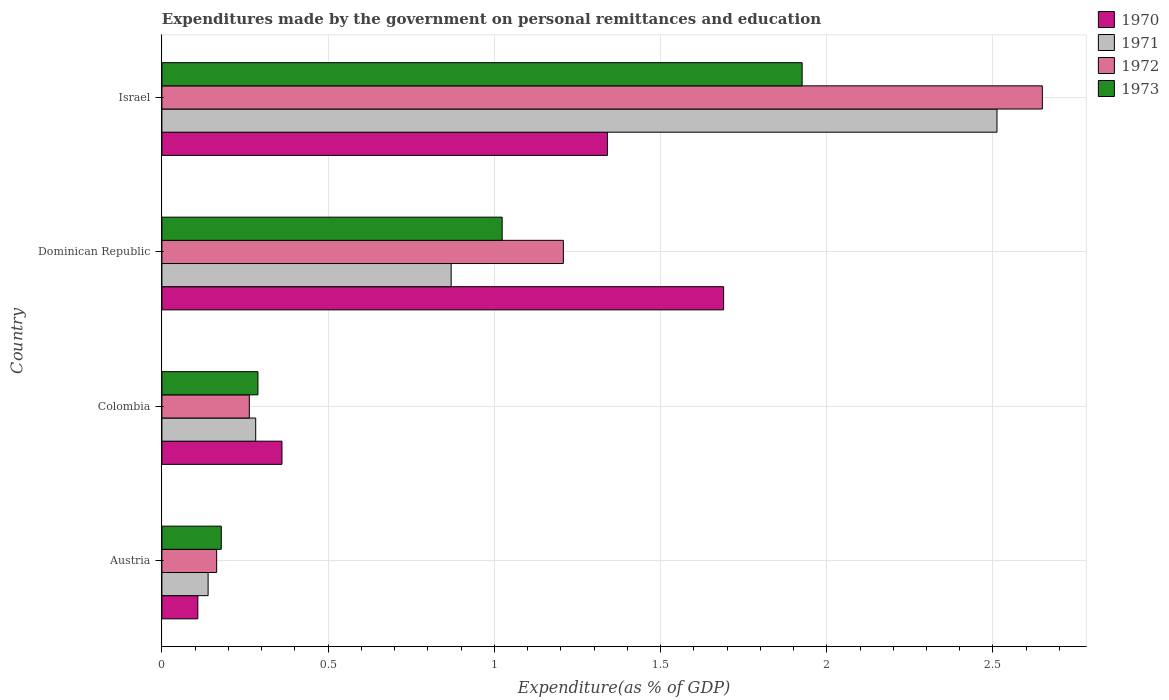How many different coloured bars are there?
Offer a very short reply. 4. How many groups of bars are there?
Your response must be concise. 4. Are the number of bars on each tick of the Y-axis equal?
Offer a very short reply. Yes. How many bars are there on the 1st tick from the top?
Ensure brevity in your answer.  4. What is the label of the 3rd group of bars from the top?
Your answer should be compact. Colombia. What is the expenditures made by the government on personal remittances and education in 1971 in Colombia?
Your response must be concise. 0.28. Across all countries, what is the maximum expenditures made by the government on personal remittances and education in 1973?
Offer a very short reply. 1.93. Across all countries, what is the minimum expenditures made by the government on personal remittances and education in 1971?
Ensure brevity in your answer.  0.14. In which country was the expenditures made by the government on personal remittances and education in 1972 maximum?
Your answer should be compact. Israel. In which country was the expenditures made by the government on personal remittances and education in 1973 minimum?
Your answer should be compact. Austria. What is the total expenditures made by the government on personal remittances and education in 1970 in the graph?
Provide a short and direct response. 3.5. What is the difference between the expenditures made by the government on personal remittances and education in 1971 in Colombia and that in Dominican Republic?
Your answer should be very brief. -0.59. What is the difference between the expenditures made by the government on personal remittances and education in 1972 in Dominican Republic and the expenditures made by the government on personal remittances and education in 1970 in Israel?
Provide a succinct answer. -0.13. What is the average expenditures made by the government on personal remittances and education in 1971 per country?
Ensure brevity in your answer.  0.95. What is the difference between the expenditures made by the government on personal remittances and education in 1973 and expenditures made by the government on personal remittances and education in 1972 in Dominican Republic?
Make the answer very short. -0.18. What is the ratio of the expenditures made by the government on personal remittances and education in 1972 in Colombia to that in Dominican Republic?
Provide a short and direct response. 0.22. Is the difference between the expenditures made by the government on personal remittances and education in 1973 in Austria and Dominican Republic greater than the difference between the expenditures made by the government on personal remittances and education in 1972 in Austria and Dominican Republic?
Give a very brief answer. Yes. What is the difference between the highest and the second highest expenditures made by the government on personal remittances and education in 1970?
Offer a terse response. 0.35. What is the difference between the highest and the lowest expenditures made by the government on personal remittances and education in 1973?
Your response must be concise. 1.75. Is it the case that in every country, the sum of the expenditures made by the government on personal remittances and education in 1971 and expenditures made by the government on personal remittances and education in 1970 is greater than the sum of expenditures made by the government on personal remittances and education in 1973 and expenditures made by the government on personal remittances and education in 1972?
Provide a succinct answer. No. What does the 4th bar from the top in Dominican Republic represents?
Your answer should be compact. 1970. What does the 4th bar from the bottom in Dominican Republic represents?
Your answer should be very brief. 1973. Are the values on the major ticks of X-axis written in scientific E-notation?
Your answer should be compact. No. Does the graph contain any zero values?
Provide a short and direct response. No. Where does the legend appear in the graph?
Provide a succinct answer. Top right. How many legend labels are there?
Offer a terse response. 4. How are the legend labels stacked?
Provide a short and direct response. Vertical. What is the title of the graph?
Ensure brevity in your answer.  Expenditures made by the government on personal remittances and education. Does "2010" appear as one of the legend labels in the graph?
Offer a very short reply. No. What is the label or title of the X-axis?
Ensure brevity in your answer.  Expenditure(as % of GDP). What is the Expenditure(as % of GDP) of 1970 in Austria?
Offer a very short reply. 0.11. What is the Expenditure(as % of GDP) in 1971 in Austria?
Your response must be concise. 0.14. What is the Expenditure(as % of GDP) of 1972 in Austria?
Your answer should be very brief. 0.16. What is the Expenditure(as % of GDP) of 1973 in Austria?
Keep it short and to the point. 0.18. What is the Expenditure(as % of GDP) of 1970 in Colombia?
Make the answer very short. 0.36. What is the Expenditure(as % of GDP) of 1971 in Colombia?
Ensure brevity in your answer.  0.28. What is the Expenditure(as % of GDP) in 1972 in Colombia?
Keep it short and to the point. 0.26. What is the Expenditure(as % of GDP) of 1973 in Colombia?
Offer a very short reply. 0.29. What is the Expenditure(as % of GDP) in 1970 in Dominican Republic?
Give a very brief answer. 1.69. What is the Expenditure(as % of GDP) in 1971 in Dominican Republic?
Provide a short and direct response. 0.87. What is the Expenditure(as % of GDP) of 1972 in Dominican Republic?
Ensure brevity in your answer.  1.21. What is the Expenditure(as % of GDP) of 1973 in Dominican Republic?
Your answer should be very brief. 1.02. What is the Expenditure(as % of GDP) of 1970 in Israel?
Your response must be concise. 1.34. What is the Expenditure(as % of GDP) in 1971 in Israel?
Your answer should be compact. 2.51. What is the Expenditure(as % of GDP) of 1972 in Israel?
Provide a short and direct response. 2.65. What is the Expenditure(as % of GDP) in 1973 in Israel?
Your response must be concise. 1.93. Across all countries, what is the maximum Expenditure(as % of GDP) of 1970?
Your response must be concise. 1.69. Across all countries, what is the maximum Expenditure(as % of GDP) in 1971?
Ensure brevity in your answer.  2.51. Across all countries, what is the maximum Expenditure(as % of GDP) of 1972?
Make the answer very short. 2.65. Across all countries, what is the maximum Expenditure(as % of GDP) of 1973?
Ensure brevity in your answer.  1.93. Across all countries, what is the minimum Expenditure(as % of GDP) in 1970?
Offer a terse response. 0.11. Across all countries, what is the minimum Expenditure(as % of GDP) in 1971?
Offer a very short reply. 0.14. Across all countries, what is the minimum Expenditure(as % of GDP) in 1972?
Offer a terse response. 0.16. Across all countries, what is the minimum Expenditure(as % of GDP) in 1973?
Your response must be concise. 0.18. What is the total Expenditure(as % of GDP) of 1970 in the graph?
Your answer should be compact. 3.5. What is the total Expenditure(as % of GDP) in 1971 in the graph?
Offer a very short reply. 3.8. What is the total Expenditure(as % of GDP) in 1972 in the graph?
Give a very brief answer. 4.28. What is the total Expenditure(as % of GDP) in 1973 in the graph?
Ensure brevity in your answer.  3.42. What is the difference between the Expenditure(as % of GDP) in 1970 in Austria and that in Colombia?
Ensure brevity in your answer.  -0.25. What is the difference between the Expenditure(as % of GDP) of 1971 in Austria and that in Colombia?
Your answer should be very brief. -0.14. What is the difference between the Expenditure(as % of GDP) in 1972 in Austria and that in Colombia?
Offer a terse response. -0.1. What is the difference between the Expenditure(as % of GDP) of 1973 in Austria and that in Colombia?
Offer a terse response. -0.11. What is the difference between the Expenditure(as % of GDP) of 1970 in Austria and that in Dominican Republic?
Keep it short and to the point. -1.58. What is the difference between the Expenditure(as % of GDP) in 1971 in Austria and that in Dominican Republic?
Your answer should be very brief. -0.73. What is the difference between the Expenditure(as % of GDP) in 1972 in Austria and that in Dominican Republic?
Ensure brevity in your answer.  -1.04. What is the difference between the Expenditure(as % of GDP) in 1973 in Austria and that in Dominican Republic?
Offer a terse response. -0.84. What is the difference between the Expenditure(as % of GDP) of 1970 in Austria and that in Israel?
Offer a very short reply. -1.23. What is the difference between the Expenditure(as % of GDP) of 1971 in Austria and that in Israel?
Provide a short and direct response. -2.37. What is the difference between the Expenditure(as % of GDP) in 1972 in Austria and that in Israel?
Provide a succinct answer. -2.48. What is the difference between the Expenditure(as % of GDP) in 1973 in Austria and that in Israel?
Ensure brevity in your answer.  -1.75. What is the difference between the Expenditure(as % of GDP) of 1970 in Colombia and that in Dominican Republic?
Your response must be concise. -1.33. What is the difference between the Expenditure(as % of GDP) of 1971 in Colombia and that in Dominican Republic?
Ensure brevity in your answer.  -0.59. What is the difference between the Expenditure(as % of GDP) in 1972 in Colombia and that in Dominican Republic?
Offer a very short reply. -0.94. What is the difference between the Expenditure(as % of GDP) of 1973 in Colombia and that in Dominican Republic?
Offer a terse response. -0.73. What is the difference between the Expenditure(as % of GDP) of 1970 in Colombia and that in Israel?
Ensure brevity in your answer.  -0.98. What is the difference between the Expenditure(as % of GDP) in 1971 in Colombia and that in Israel?
Your answer should be compact. -2.23. What is the difference between the Expenditure(as % of GDP) in 1972 in Colombia and that in Israel?
Ensure brevity in your answer.  -2.39. What is the difference between the Expenditure(as % of GDP) in 1973 in Colombia and that in Israel?
Offer a terse response. -1.64. What is the difference between the Expenditure(as % of GDP) of 1970 in Dominican Republic and that in Israel?
Keep it short and to the point. 0.35. What is the difference between the Expenditure(as % of GDP) in 1971 in Dominican Republic and that in Israel?
Provide a short and direct response. -1.64. What is the difference between the Expenditure(as % of GDP) in 1972 in Dominican Republic and that in Israel?
Make the answer very short. -1.44. What is the difference between the Expenditure(as % of GDP) in 1973 in Dominican Republic and that in Israel?
Provide a succinct answer. -0.9. What is the difference between the Expenditure(as % of GDP) of 1970 in Austria and the Expenditure(as % of GDP) of 1971 in Colombia?
Ensure brevity in your answer.  -0.17. What is the difference between the Expenditure(as % of GDP) in 1970 in Austria and the Expenditure(as % of GDP) in 1972 in Colombia?
Make the answer very short. -0.15. What is the difference between the Expenditure(as % of GDP) of 1970 in Austria and the Expenditure(as % of GDP) of 1973 in Colombia?
Give a very brief answer. -0.18. What is the difference between the Expenditure(as % of GDP) in 1971 in Austria and the Expenditure(as % of GDP) in 1972 in Colombia?
Keep it short and to the point. -0.12. What is the difference between the Expenditure(as % of GDP) of 1971 in Austria and the Expenditure(as % of GDP) of 1973 in Colombia?
Give a very brief answer. -0.15. What is the difference between the Expenditure(as % of GDP) in 1972 in Austria and the Expenditure(as % of GDP) in 1973 in Colombia?
Make the answer very short. -0.12. What is the difference between the Expenditure(as % of GDP) in 1970 in Austria and the Expenditure(as % of GDP) in 1971 in Dominican Republic?
Your answer should be compact. -0.76. What is the difference between the Expenditure(as % of GDP) in 1970 in Austria and the Expenditure(as % of GDP) in 1972 in Dominican Republic?
Ensure brevity in your answer.  -1.1. What is the difference between the Expenditure(as % of GDP) in 1970 in Austria and the Expenditure(as % of GDP) in 1973 in Dominican Republic?
Your response must be concise. -0.92. What is the difference between the Expenditure(as % of GDP) of 1971 in Austria and the Expenditure(as % of GDP) of 1972 in Dominican Republic?
Offer a very short reply. -1.07. What is the difference between the Expenditure(as % of GDP) of 1971 in Austria and the Expenditure(as % of GDP) of 1973 in Dominican Republic?
Make the answer very short. -0.88. What is the difference between the Expenditure(as % of GDP) in 1972 in Austria and the Expenditure(as % of GDP) in 1973 in Dominican Republic?
Provide a succinct answer. -0.86. What is the difference between the Expenditure(as % of GDP) of 1970 in Austria and the Expenditure(as % of GDP) of 1971 in Israel?
Give a very brief answer. -2.4. What is the difference between the Expenditure(as % of GDP) in 1970 in Austria and the Expenditure(as % of GDP) in 1972 in Israel?
Provide a succinct answer. -2.54. What is the difference between the Expenditure(as % of GDP) in 1970 in Austria and the Expenditure(as % of GDP) in 1973 in Israel?
Your answer should be compact. -1.82. What is the difference between the Expenditure(as % of GDP) in 1971 in Austria and the Expenditure(as % of GDP) in 1972 in Israel?
Offer a very short reply. -2.51. What is the difference between the Expenditure(as % of GDP) in 1971 in Austria and the Expenditure(as % of GDP) in 1973 in Israel?
Provide a short and direct response. -1.79. What is the difference between the Expenditure(as % of GDP) in 1972 in Austria and the Expenditure(as % of GDP) in 1973 in Israel?
Keep it short and to the point. -1.76. What is the difference between the Expenditure(as % of GDP) in 1970 in Colombia and the Expenditure(as % of GDP) in 1971 in Dominican Republic?
Provide a short and direct response. -0.51. What is the difference between the Expenditure(as % of GDP) in 1970 in Colombia and the Expenditure(as % of GDP) in 1972 in Dominican Republic?
Offer a terse response. -0.85. What is the difference between the Expenditure(as % of GDP) of 1970 in Colombia and the Expenditure(as % of GDP) of 1973 in Dominican Republic?
Your response must be concise. -0.66. What is the difference between the Expenditure(as % of GDP) of 1971 in Colombia and the Expenditure(as % of GDP) of 1972 in Dominican Republic?
Provide a succinct answer. -0.93. What is the difference between the Expenditure(as % of GDP) in 1971 in Colombia and the Expenditure(as % of GDP) in 1973 in Dominican Republic?
Offer a very short reply. -0.74. What is the difference between the Expenditure(as % of GDP) of 1972 in Colombia and the Expenditure(as % of GDP) of 1973 in Dominican Republic?
Your answer should be very brief. -0.76. What is the difference between the Expenditure(as % of GDP) of 1970 in Colombia and the Expenditure(as % of GDP) of 1971 in Israel?
Make the answer very short. -2.15. What is the difference between the Expenditure(as % of GDP) of 1970 in Colombia and the Expenditure(as % of GDP) of 1972 in Israel?
Offer a terse response. -2.29. What is the difference between the Expenditure(as % of GDP) in 1970 in Colombia and the Expenditure(as % of GDP) in 1973 in Israel?
Give a very brief answer. -1.56. What is the difference between the Expenditure(as % of GDP) of 1971 in Colombia and the Expenditure(as % of GDP) of 1972 in Israel?
Provide a short and direct response. -2.37. What is the difference between the Expenditure(as % of GDP) in 1971 in Colombia and the Expenditure(as % of GDP) in 1973 in Israel?
Make the answer very short. -1.64. What is the difference between the Expenditure(as % of GDP) in 1972 in Colombia and the Expenditure(as % of GDP) in 1973 in Israel?
Provide a succinct answer. -1.66. What is the difference between the Expenditure(as % of GDP) of 1970 in Dominican Republic and the Expenditure(as % of GDP) of 1971 in Israel?
Provide a succinct answer. -0.82. What is the difference between the Expenditure(as % of GDP) of 1970 in Dominican Republic and the Expenditure(as % of GDP) of 1972 in Israel?
Make the answer very short. -0.96. What is the difference between the Expenditure(as % of GDP) in 1970 in Dominican Republic and the Expenditure(as % of GDP) in 1973 in Israel?
Provide a succinct answer. -0.24. What is the difference between the Expenditure(as % of GDP) of 1971 in Dominican Republic and the Expenditure(as % of GDP) of 1972 in Israel?
Your answer should be very brief. -1.78. What is the difference between the Expenditure(as % of GDP) in 1971 in Dominican Republic and the Expenditure(as % of GDP) in 1973 in Israel?
Offer a terse response. -1.06. What is the difference between the Expenditure(as % of GDP) in 1972 in Dominican Republic and the Expenditure(as % of GDP) in 1973 in Israel?
Your answer should be compact. -0.72. What is the average Expenditure(as % of GDP) of 1970 per country?
Offer a terse response. 0.87. What is the average Expenditure(as % of GDP) of 1971 per country?
Provide a succinct answer. 0.95. What is the average Expenditure(as % of GDP) of 1972 per country?
Provide a succinct answer. 1.07. What is the average Expenditure(as % of GDP) of 1973 per country?
Provide a short and direct response. 0.85. What is the difference between the Expenditure(as % of GDP) in 1970 and Expenditure(as % of GDP) in 1971 in Austria?
Provide a short and direct response. -0.03. What is the difference between the Expenditure(as % of GDP) of 1970 and Expenditure(as % of GDP) of 1972 in Austria?
Your response must be concise. -0.06. What is the difference between the Expenditure(as % of GDP) in 1970 and Expenditure(as % of GDP) in 1973 in Austria?
Provide a short and direct response. -0.07. What is the difference between the Expenditure(as % of GDP) of 1971 and Expenditure(as % of GDP) of 1972 in Austria?
Keep it short and to the point. -0.03. What is the difference between the Expenditure(as % of GDP) in 1971 and Expenditure(as % of GDP) in 1973 in Austria?
Offer a very short reply. -0.04. What is the difference between the Expenditure(as % of GDP) of 1972 and Expenditure(as % of GDP) of 1973 in Austria?
Make the answer very short. -0.01. What is the difference between the Expenditure(as % of GDP) in 1970 and Expenditure(as % of GDP) in 1971 in Colombia?
Make the answer very short. 0.08. What is the difference between the Expenditure(as % of GDP) in 1970 and Expenditure(as % of GDP) in 1972 in Colombia?
Keep it short and to the point. 0.1. What is the difference between the Expenditure(as % of GDP) in 1970 and Expenditure(as % of GDP) in 1973 in Colombia?
Offer a terse response. 0.07. What is the difference between the Expenditure(as % of GDP) of 1971 and Expenditure(as % of GDP) of 1972 in Colombia?
Provide a succinct answer. 0.02. What is the difference between the Expenditure(as % of GDP) of 1971 and Expenditure(as % of GDP) of 1973 in Colombia?
Your answer should be compact. -0.01. What is the difference between the Expenditure(as % of GDP) in 1972 and Expenditure(as % of GDP) in 1973 in Colombia?
Your answer should be compact. -0.03. What is the difference between the Expenditure(as % of GDP) of 1970 and Expenditure(as % of GDP) of 1971 in Dominican Republic?
Offer a terse response. 0.82. What is the difference between the Expenditure(as % of GDP) in 1970 and Expenditure(as % of GDP) in 1972 in Dominican Republic?
Offer a terse response. 0.48. What is the difference between the Expenditure(as % of GDP) in 1970 and Expenditure(as % of GDP) in 1973 in Dominican Republic?
Give a very brief answer. 0.67. What is the difference between the Expenditure(as % of GDP) of 1971 and Expenditure(as % of GDP) of 1972 in Dominican Republic?
Ensure brevity in your answer.  -0.34. What is the difference between the Expenditure(as % of GDP) in 1971 and Expenditure(as % of GDP) in 1973 in Dominican Republic?
Offer a terse response. -0.15. What is the difference between the Expenditure(as % of GDP) of 1972 and Expenditure(as % of GDP) of 1973 in Dominican Republic?
Ensure brevity in your answer.  0.18. What is the difference between the Expenditure(as % of GDP) in 1970 and Expenditure(as % of GDP) in 1971 in Israel?
Your response must be concise. -1.17. What is the difference between the Expenditure(as % of GDP) of 1970 and Expenditure(as % of GDP) of 1972 in Israel?
Offer a very short reply. -1.31. What is the difference between the Expenditure(as % of GDP) of 1970 and Expenditure(as % of GDP) of 1973 in Israel?
Make the answer very short. -0.59. What is the difference between the Expenditure(as % of GDP) of 1971 and Expenditure(as % of GDP) of 1972 in Israel?
Ensure brevity in your answer.  -0.14. What is the difference between the Expenditure(as % of GDP) in 1971 and Expenditure(as % of GDP) in 1973 in Israel?
Make the answer very short. 0.59. What is the difference between the Expenditure(as % of GDP) of 1972 and Expenditure(as % of GDP) of 1973 in Israel?
Your response must be concise. 0.72. What is the ratio of the Expenditure(as % of GDP) in 1970 in Austria to that in Colombia?
Your answer should be very brief. 0.3. What is the ratio of the Expenditure(as % of GDP) in 1971 in Austria to that in Colombia?
Ensure brevity in your answer.  0.49. What is the ratio of the Expenditure(as % of GDP) in 1972 in Austria to that in Colombia?
Offer a very short reply. 0.63. What is the ratio of the Expenditure(as % of GDP) in 1973 in Austria to that in Colombia?
Provide a short and direct response. 0.62. What is the ratio of the Expenditure(as % of GDP) of 1970 in Austria to that in Dominican Republic?
Keep it short and to the point. 0.06. What is the ratio of the Expenditure(as % of GDP) in 1971 in Austria to that in Dominican Republic?
Ensure brevity in your answer.  0.16. What is the ratio of the Expenditure(as % of GDP) of 1972 in Austria to that in Dominican Republic?
Offer a terse response. 0.14. What is the ratio of the Expenditure(as % of GDP) of 1973 in Austria to that in Dominican Republic?
Provide a short and direct response. 0.17. What is the ratio of the Expenditure(as % of GDP) of 1970 in Austria to that in Israel?
Ensure brevity in your answer.  0.08. What is the ratio of the Expenditure(as % of GDP) of 1971 in Austria to that in Israel?
Provide a succinct answer. 0.06. What is the ratio of the Expenditure(as % of GDP) of 1972 in Austria to that in Israel?
Provide a short and direct response. 0.06. What is the ratio of the Expenditure(as % of GDP) in 1973 in Austria to that in Israel?
Give a very brief answer. 0.09. What is the ratio of the Expenditure(as % of GDP) of 1970 in Colombia to that in Dominican Republic?
Provide a short and direct response. 0.21. What is the ratio of the Expenditure(as % of GDP) in 1971 in Colombia to that in Dominican Republic?
Give a very brief answer. 0.32. What is the ratio of the Expenditure(as % of GDP) of 1972 in Colombia to that in Dominican Republic?
Your answer should be compact. 0.22. What is the ratio of the Expenditure(as % of GDP) in 1973 in Colombia to that in Dominican Republic?
Make the answer very short. 0.28. What is the ratio of the Expenditure(as % of GDP) of 1970 in Colombia to that in Israel?
Offer a terse response. 0.27. What is the ratio of the Expenditure(as % of GDP) in 1971 in Colombia to that in Israel?
Ensure brevity in your answer.  0.11. What is the ratio of the Expenditure(as % of GDP) in 1972 in Colombia to that in Israel?
Offer a very short reply. 0.1. What is the ratio of the Expenditure(as % of GDP) in 1973 in Colombia to that in Israel?
Provide a succinct answer. 0.15. What is the ratio of the Expenditure(as % of GDP) of 1970 in Dominican Republic to that in Israel?
Ensure brevity in your answer.  1.26. What is the ratio of the Expenditure(as % of GDP) of 1971 in Dominican Republic to that in Israel?
Provide a short and direct response. 0.35. What is the ratio of the Expenditure(as % of GDP) in 1972 in Dominican Republic to that in Israel?
Provide a short and direct response. 0.46. What is the ratio of the Expenditure(as % of GDP) in 1973 in Dominican Republic to that in Israel?
Your answer should be very brief. 0.53. What is the difference between the highest and the second highest Expenditure(as % of GDP) in 1970?
Keep it short and to the point. 0.35. What is the difference between the highest and the second highest Expenditure(as % of GDP) of 1971?
Provide a short and direct response. 1.64. What is the difference between the highest and the second highest Expenditure(as % of GDP) in 1972?
Keep it short and to the point. 1.44. What is the difference between the highest and the second highest Expenditure(as % of GDP) in 1973?
Provide a short and direct response. 0.9. What is the difference between the highest and the lowest Expenditure(as % of GDP) of 1970?
Your response must be concise. 1.58. What is the difference between the highest and the lowest Expenditure(as % of GDP) in 1971?
Keep it short and to the point. 2.37. What is the difference between the highest and the lowest Expenditure(as % of GDP) of 1972?
Provide a short and direct response. 2.48. What is the difference between the highest and the lowest Expenditure(as % of GDP) of 1973?
Your answer should be compact. 1.75. 